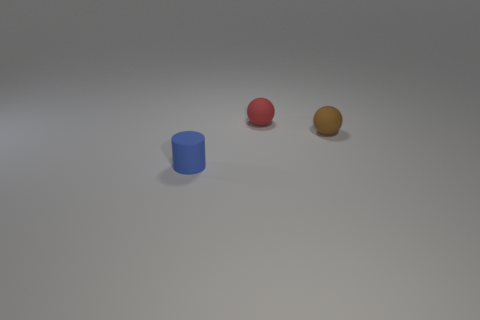Is there any other thing of the same color as the matte cylinder?
Your response must be concise. No. What size is the rubber object behind the brown matte ball?
Provide a short and direct response. Small. There is a rubber sphere that is behind the matte sphere in front of the small rubber sphere that is behind the tiny brown object; how big is it?
Ensure brevity in your answer.  Small. What color is the thing behind the ball right of the tiny red sphere?
Your response must be concise. Red. There is another small object that is the same shape as the tiny brown object; what is it made of?
Give a very brief answer. Rubber. Are there any other things that have the same material as the brown sphere?
Give a very brief answer. Yes. Are there any spheres right of the brown matte thing?
Give a very brief answer. No. What number of big shiny balls are there?
Your answer should be compact. 0. There is a tiny matte ball in front of the red rubber thing; how many small brown matte spheres are in front of it?
Offer a terse response. 0. Is the color of the tiny cylinder the same as the tiny thing that is behind the tiny brown ball?
Make the answer very short. No. 